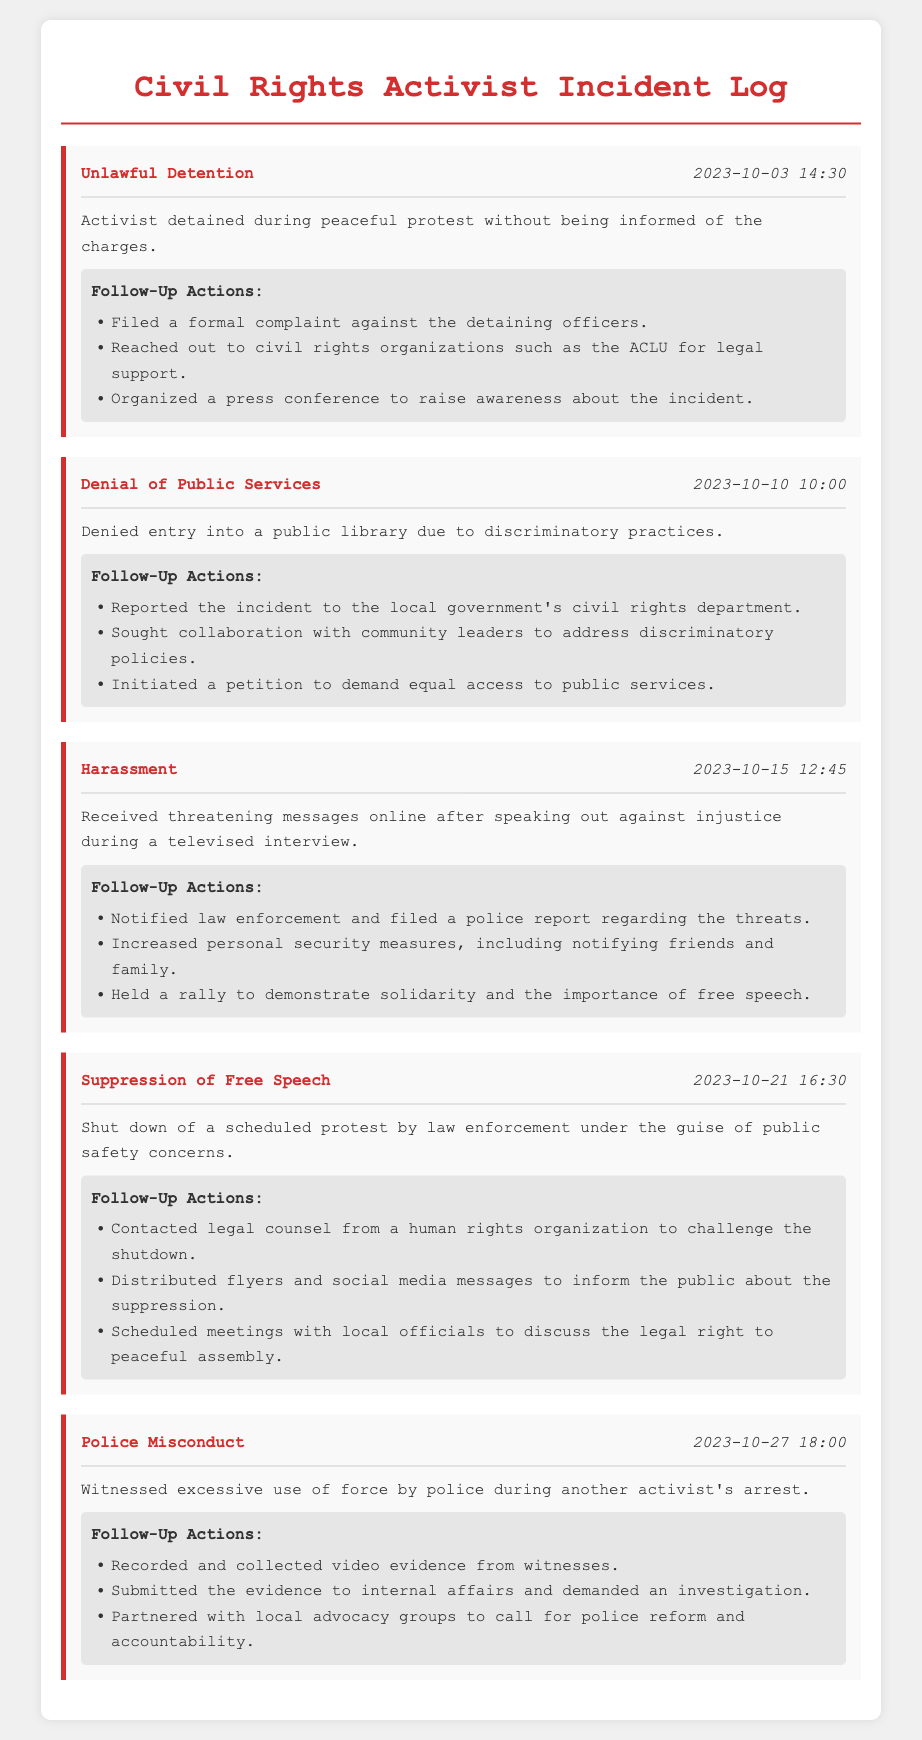What was the nature of the incident on 2023-10-03? The nature of the incident reported on 2023-10-03 was "Unlawful Detention."
Answer: Unlawful Detention What time did the incident regarding "Denial of Public Services" occur? The incident regarding "Denial of Public Services" occurred at 10:00.
Answer: 10:00 How many follow-up actions were taken for the incident on 2023-10-15? There were three follow-up actions taken for the incident on 2023-10-15.
Answer: Three What was the primary action taken after the "Suppression of Free Speech" incident? The primary action taken was to contact legal counsel to challenge the shutdown.
Answer: Contacted legal counsel Which incident involved the witness of excessive use of force by police? The incident that involved witness of excessive use of force by police was "Police Misconduct."
Answer: Police Misconduct On which date did the "Harassment" incident occur? The "Harassment" incident occurred on 2023-10-15.
Answer: 2023-10-15 Who reached out for legal support after the "Unlawful Detention"? The activist reached out to civil rights organizations for legal support after the "Unlawful Detention."
Answer: Civil rights organizations What was the date of the "Police Misconduct" incident? The date of the "Police Misconduct" incident is 2023-10-27.
Answer: 2023-10-27 What was organized to raise awareness about the "Unlawful Detention"? A press conference was organized to raise awareness about the "Unlawful Detention."
Answer: Press conference 